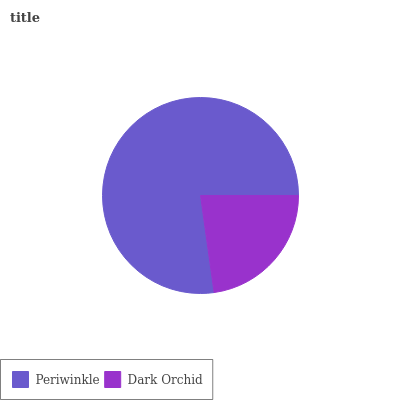Is Dark Orchid the minimum?
Answer yes or no. Yes. Is Periwinkle the maximum?
Answer yes or no. Yes. Is Dark Orchid the maximum?
Answer yes or no. No. Is Periwinkle greater than Dark Orchid?
Answer yes or no. Yes. Is Dark Orchid less than Periwinkle?
Answer yes or no. Yes. Is Dark Orchid greater than Periwinkle?
Answer yes or no. No. Is Periwinkle less than Dark Orchid?
Answer yes or no. No. Is Periwinkle the high median?
Answer yes or no. Yes. Is Dark Orchid the low median?
Answer yes or no. Yes. Is Dark Orchid the high median?
Answer yes or no. No. Is Periwinkle the low median?
Answer yes or no. No. 